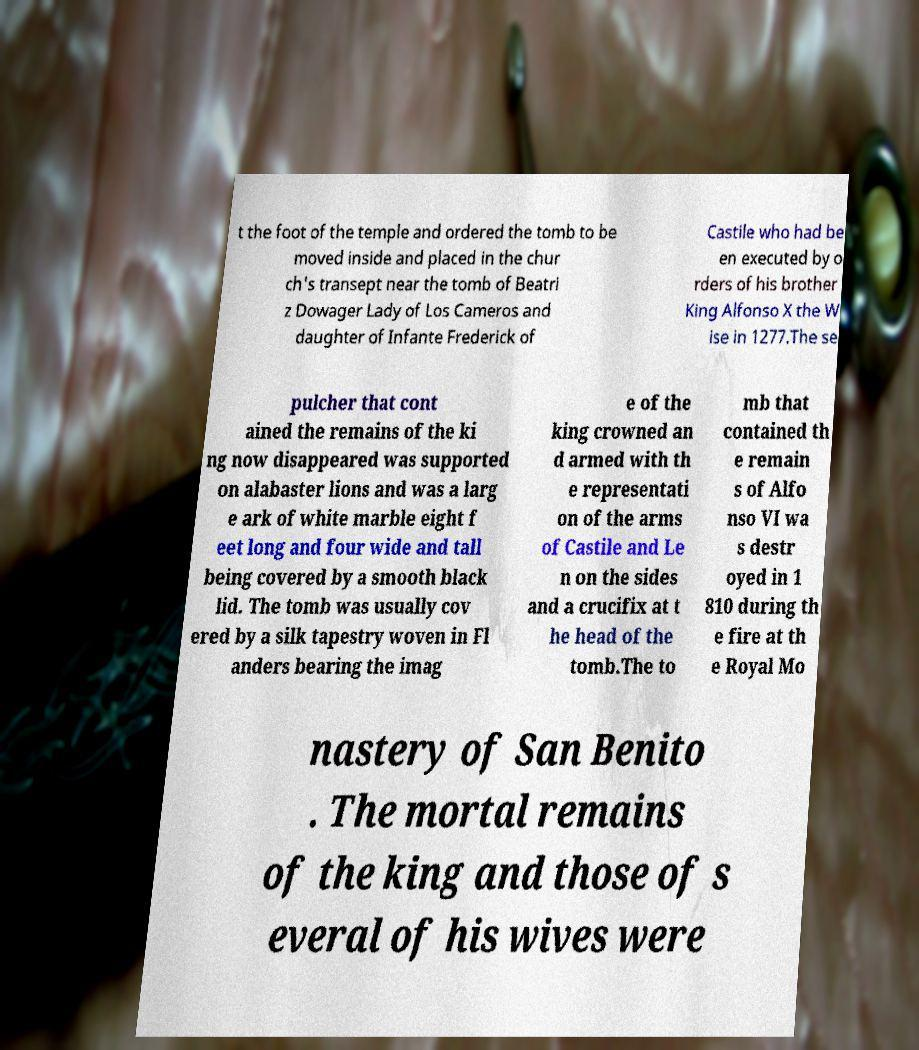Could you extract and type out the text from this image? t the foot of the temple and ordered the tomb to be moved inside and placed in the chur ch's transept near the tomb of Beatri z Dowager Lady of Los Cameros and daughter of Infante Frederick of Castile who had be en executed by o rders of his brother King Alfonso X the W ise in 1277.The se pulcher that cont ained the remains of the ki ng now disappeared was supported on alabaster lions and was a larg e ark of white marble eight f eet long and four wide and tall being covered by a smooth black lid. The tomb was usually cov ered by a silk tapestry woven in Fl anders bearing the imag e of the king crowned an d armed with th e representati on of the arms of Castile and Le n on the sides and a crucifix at t he head of the tomb.The to mb that contained th e remain s of Alfo nso VI wa s destr oyed in 1 810 during th e fire at th e Royal Mo nastery of San Benito . The mortal remains of the king and those of s everal of his wives were 